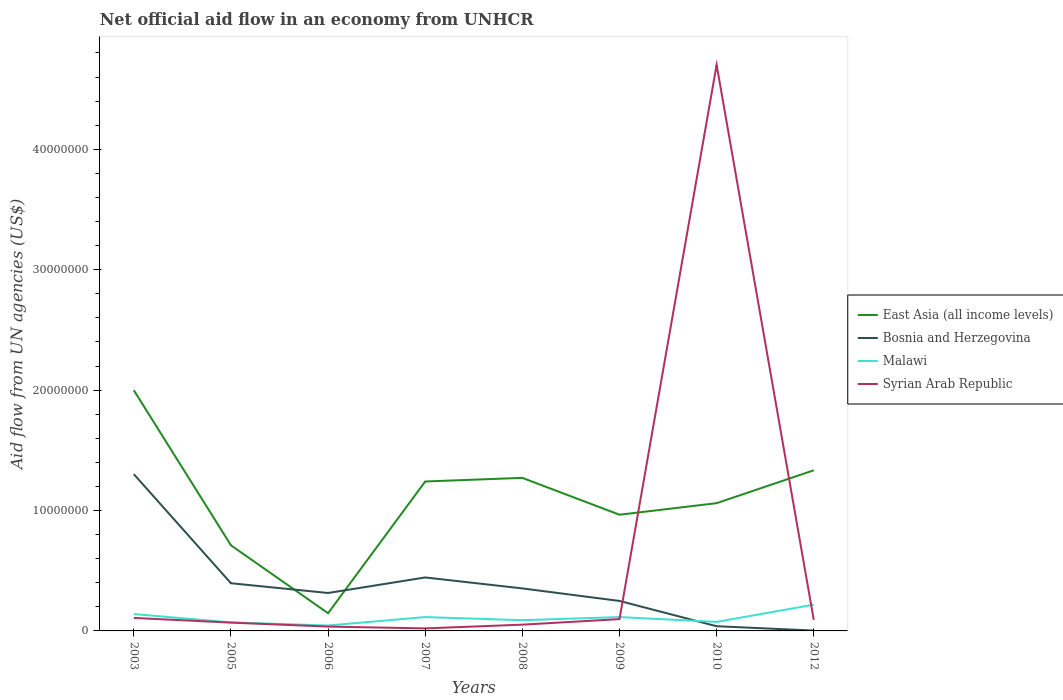How many different coloured lines are there?
Provide a short and direct response. 4. What is the total net official aid flow in Bosnia and Herzegovina in the graph?
Your response must be concise. 2.10e+06. What is the difference between the highest and the second highest net official aid flow in East Asia (all income levels)?
Your answer should be very brief. 1.85e+07. How many lines are there?
Provide a succinct answer. 4. What is the difference between two consecutive major ticks on the Y-axis?
Give a very brief answer. 1.00e+07. Are the values on the major ticks of Y-axis written in scientific E-notation?
Offer a very short reply. No. Does the graph contain grids?
Provide a short and direct response. No. What is the title of the graph?
Give a very brief answer. Net official aid flow in an economy from UNHCR. What is the label or title of the X-axis?
Provide a short and direct response. Years. What is the label or title of the Y-axis?
Offer a very short reply. Aid flow from UN agencies (US$). What is the Aid flow from UN agencies (US$) in East Asia (all income levels) in 2003?
Make the answer very short. 2.00e+07. What is the Aid flow from UN agencies (US$) of Bosnia and Herzegovina in 2003?
Offer a terse response. 1.30e+07. What is the Aid flow from UN agencies (US$) in Malawi in 2003?
Offer a very short reply. 1.40e+06. What is the Aid flow from UN agencies (US$) of Syrian Arab Republic in 2003?
Provide a succinct answer. 1.08e+06. What is the Aid flow from UN agencies (US$) in East Asia (all income levels) in 2005?
Offer a terse response. 7.11e+06. What is the Aid flow from UN agencies (US$) of Bosnia and Herzegovina in 2005?
Provide a succinct answer. 3.96e+06. What is the Aid flow from UN agencies (US$) of Malawi in 2005?
Ensure brevity in your answer.  7.10e+05. What is the Aid flow from UN agencies (US$) of Syrian Arab Republic in 2005?
Offer a very short reply. 6.90e+05. What is the Aid flow from UN agencies (US$) of East Asia (all income levels) in 2006?
Offer a very short reply. 1.47e+06. What is the Aid flow from UN agencies (US$) of Bosnia and Herzegovina in 2006?
Provide a succinct answer. 3.15e+06. What is the Aid flow from UN agencies (US$) in Malawi in 2006?
Ensure brevity in your answer.  4.50e+05. What is the Aid flow from UN agencies (US$) in Syrian Arab Republic in 2006?
Your answer should be compact. 3.60e+05. What is the Aid flow from UN agencies (US$) of East Asia (all income levels) in 2007?
Ensure brevity in your answer.  1.24e+07. What is the Aid flow from UN agencies (US$) in Bosnia and Herzegovina in 2007?
Offer a very short reply. 4.44e+06. What is the Aid flow from UN agencies (US$) of Malawi in 2007?
Keep it short and to the point. 1.15e+06. What is the Aid flow from UN agencies (US$) of Syrian Arab Republic in 2007?
Provide a short and direct response. 2.10e+05. What is the Aid flow from UN agencies (US$) in East Asia (all income levels) in 2008?
Your answer should be very brief. 1.27e+07. What is the Aid flow from UN agencies (US$) of Bosnia and Herzegovina in 2008?
Provide a succinct answer. 3.53e+06. What is the Aid flow from UN agencies (US$) of Malawi in 2008?
Offer a terse response. 8.90e+05. What is the Aid flow from UN agencies (US$) of Syrian Arab Republic in 2008?
Ensure brevity in your answer.  5.20e+05. What is the Aid flow from UN agencies (US$) in East Asia (all income levels) in 2009?
Your response must be concise. 9.65e+06. What is the Aid flow from UN agencies (US$) of Bosnia and Herzegovina in 2009?
Give a very brief answer. 2.49e+06. What is the Aid flow from UN agencies (US$) in Malawi in 2009?
Offer a very short reply. 1.15e+06. What is the Aid flow from UN agencies (US$) in Syrian Arab Republic in 2009?
Your answer should be very brief. 9.80e+05. What is the Aid flow from UN agencies (US$) of East Asia (all income levels) in 2010?
Make the answer very short. 1.06e+07. What is the Aid flow from UN agencies (US$) of Malawi in 2010?
Give a very brief answer. 7.50e+05. What is the Aid flow from UN agencies (US$) in Syrian Arab Republic in 2010?
Provide a short and direct response. 4.70e+07. What is the Aid flow from UN agencies (US$) in East Asia (all income levels) in 2012?
Your answer should be very brief. 1.33e+07. What is the Aid flow from UN agencies (US$) of Bosnia and Herzegovina in 2012?
Provide a succinct answer. 3.00e+04. What is the Aid flow from UN agencies (US$) of Malawi in 2012?
Offer a very short reply. 2.18e+06. What is the Aid flow from UN agencies (US$) of Syrian Arab Republic in 2012?
Keep it short and to the point. 9.20e+05. Across all years, what is the maximum Aid flow from UN agencies (US$) in East Asia (all income levels)?
Offer a terse response. 2.00e+07. Across all years, what is the maximum Aid flow from UN agencies (US$) of Bosnia and Herzegovina?
Make the answer very short. 1.30e+07. Across all years, what is the maximum Aid flow from UN agencies (US$) of Malawi?
Your answer should be compact. 2.18e+06. Across all years, what is the maximum Aid flow from UN agencies (US$) of Syrian Arab Republic?
Your answer should be very brief. 4.70e+07. Across all years, what is the minimum Aid flow from UN agencies (US$) in East Asia (all income levels)?
Your answer should be very brief. 1.47e+06. Across all years, what is the minimum Aid flow from UN agencies (US$) of Bosnia and Herzegovina?
Ensure brevity in your answer.  3.00e+04. What is the total Aid flow from UN agencies (US$) in East Asia (all income levels) in the graph?
Your response must be concise. 8.73e+07. What is the total Aid flow from UN agencies (US$) in Bosnia and Herzegovina in the graph?
Your answer should be very brief. 3.10e+07. What is the total Aid flow from UN agencies (US$) in Malawi in the graph?
Make the answer very short. 8.68e+06. What is the total Aid flow from UN agencies (US$) of Syrian Arab Republic in the graph?
Keep it short and to the point. 5.18e+07. What is the difference between the Aid flow from UN agencies (US$) in East Asia (all income levels) in 2003 and that in 2005?
Offer a terse response. 1.29e+07. What is the difference between the Aid flow from UN agencies (US$) in Bosnia and Herzegovina in 2003 and that in 2005?
Keep it short and to the point. 9.06e+06. What is the difference between the Aid flow from UN agencies (US$) in Malawi in 2003 and that in 2005?
Your answer should be very brief. 6.90e+05. What is the difference between the Aid flow from UN agencies (US$) of East Asia (all income levels) in 2003 and that in 2006?
Make the answer very short. 1.85e+07. What is the difference between the Aid flow from UN agencies (US$) of Bosnia and Herzegovina in 2003 and that in 2006?
Keep it short and to the point. 9.87e+06. What is the difference between the Aid flow from UN agencies (US$) in Malawi in 2003 and that in 2006?
Offer a terse response. 9.50e+05. What is the difference between the Aid flow from UN agencies (US$) of Syrian Arab Republic in 2003 and that in 2006?
Provide a succinct answer. 7.20e+05. What is the difference between the Aid flow from UN agencies (US$) of East Asia (all income levels) in 2003 and that in 2007?
Offer a terse response. 7.58e+06. What is the difference between the Aid flow from UN agencies (US$) in Bosnia and Herzegovina in 2003 and that in 2007?
Provide a short and direct response. 8.58e+06. What is the difference between the Aid flow from UN agencies (US$) of Malawi in 2003 and that in 2007?
Your answer should be compact. 2.50e+05. What is the difference between the Aid flow from UN agencies (US$) in Syrian Arab Republic in 2003 and that in 2007?
Your answer should be compact. 8.70e+05. What is the difference between the Aid flow from UN agencies (US$) of East Asia (all income levels) in 2003 and that in 2008?
Provide a succinct answer. 7.28e+06. What is the difference between the Aid flow from UN agencies (US$) of Bosnia and Herzegovina in 2003 and that in 2008?
Ensure brevity in your answer.  9.49e+06. What is the difference between the Aid flow from UN agencies (US$) in Malawi in 2003 and that in 2008?
Provide a succinct answer. 5.10e+05. What is the difference between the Aid flow from UN agencies (US$) in Syrian Arab Republic in 2003 and that in 2008?
Give a very brief answer. 5.60e+05. What is the difference between the Aid flow from UN agencies (US$) of East Asia (all income levels) in 2003 and that in 2009?
Your answer should be very brief. 1.03e+07. What is the difference between the Aid flow from UN agencies (US$) in Bosnia and Herzegovina in 2003 and that in 2009?
Your answer should be compact. 1.05e+07. What is the difference between the Aid flow from UN agencies (US$) in East Asia (all income levels) in 2003 and that in 2010?
Keep it short and to the point. 9.38e+06. What is the difference between the Aid flow from UN agencies (US$) of Bosnia and Herzegovina in 2003 and that in 2010?
Your response must be concise. 1.26e+07. What is the difference between the Aid flow from UN agencies (US$) of Malawi in 2003 and that in 2010?
Your answer should be very brief. 6.50e+05. What is the difference between the Aid flow from UN agencies (US$) of Syrian Arab Republic in 2003 and that in 2010?
Keep it short and to the point. -4.59e+07. What is the difference between the Aid flow from UN agencies (US$) in East Asia (all income levels) in 2003 and that in 2012?
Offer a very short reply. 6.65e+06. What is the difference between the Aid flow from UN agencies (US$) of Bosnia and Herzegovina in 2003 and that in 2012?
Give a very brief answer. 1.30e+07. What is the difference between the Aid flow from UN agencies (US$) of Malawi in 2003 and that in 2012?
Your answer should be compact. -7.80e+05. What is the difference between the Aid flow from UN agencies (US$) in Syrian Arab Republic in 2003 and that in 2012?
Make the answer very short. 1.60e+05. What is the difference between the Aid flow from UN agencies (US$) of East Asia (all income levels) in 2005 and that in 2006?
Offer a very short reply. 5.64e+06. What is the difference between the Aid flow from UN agencies (US$) of Bosnia and Herzegovina in 2005 and that in 2006?
Offer a terse response. 8.10e+05. What is the difference between the Aid flow from UN agencies (US$) of Syrian Arab Republic in 2005 and that in 2006?
Give a very brief answer. 3.30e+05. What is the difference between the Aid flow from UN agencies (US$) of East Asia (all income levels) in 2005 and that in 2007?
Offer a terse response. -5.30e+06. What is the difference between the Aid flow from UN agencies (US$) in Bosnia and Herzegovina in 2005 and that in 2007?
Offer a very short reply. -4.80e+05. What is the difference between the Aid flow from UN agencies (US$) in Malawi in 2005 and that in 2007?
Keep it short and to the point. -4.40e+05. What is the difference between the Aid flow from UN agencies (US$) in East Asia (all income levels) in 2005 and that in 2008?
Your answer should be very brief. -5.60e+06. What is the difference between the Aid flow from UN agencies (US$) in Bosnia and Herzegovina in 2005 and that in 2008?
Provide a succinct answer. 4.30e+05. What is the difference between the Aid flow from UN agencies (US$) of Malawi in 2005 and that in 2008?
Ensure brevity in your answer.  -1.80e+05. What is the difference between the Aid flow from UN agencies (US$) of East Asia (all income levels) in 2005 and that in 2009?
Provide a succinct answer. -2.54e+06. What is the difference between the Aid flow from UN agencies (US$) of Bosnia and Herzegovina in 2005 and that in 2009?
Offer a terse response. 1.47e+06. What is the difference between the Aid flow from UN agencies (US$) in Malawi in 2005 and that in 2009?
Provide a short and direct response. -4.40e+05. What is the difference between the Aid flow from UN agencies (US$) in East Asia (all income levels) in 2005 and that in 2010?
Give a very brief answer. -3.50e+06. What is the difference between the Aid flow from UN agencies (US$) of Bosnia and Herzegovina in 2005 and that in 2010?
Give a very brief answer. 3.57e+06. What is the difference between the Aid flow from UN agencies (US$) of Malawi in 2005 and that in 2010?
Offer a terse response. -4.00e+04. What is the difference between the Aid flow from UN agencies (US$) of Syrian Arab Republic in 2005 and that in 2010?
Make the answer very short. -4.63e+07. What is the difference between the Aid flow from UN agencies (US$) of East Asia (all income levels) in 2005 and that in 2012?
Keep it short and to the point. -6.23e+06. What is the difference between the Aid flow from UN agencies (US$) of Bosnia and Herzegovina in 2005 and that in 2012?
Provide a short and direct response. 3.93e+06. What is the difference between the Aid flow from UN agencies (US$) of Malawi in 2005 and that in 2012?
Ensure brevity in your answer.  -1.47e+06. What is the difference between the Aid flow from UN agencies (US$) of East Asia (all income levels) in 2006 and that in 2007?
Offer a very short reply. -1.09e+07. What is the difference between the Aid flow from UN agencies (US$) in Bosnia and Herzegovina in 2006 and that in 2007?
Your answer should be compact. -1.29e+06. What is the difference between the Aid flow from UN agencies (US$) of Malawi in 2006 and that in 2007?
Give a very brief answer. -7.00e+05. What is the difference between the Aid flow from UN agencies (US$) of Syrian Arab Republic in 2006 and that in 2007?
Make the answer very short. 1.50e+05. What is the difference between the Aid flow from UN agencies (US$) of East Asia (all income levels) in 2006 and that in 2008?
Give a very brief answer. -1.12e+07. What is the difference between the Aid flow from UN agencies (US$) in Bosnia and Herzegovina in 2006 and that in 2008?
Make the answer very short. -3.80e+05. What is the difference between the Aid flow from UN agencies (US$) of Malawi in 2006 and that in 2008?
Ensure brevity in your answer.  -4.40e+05. What is the difference between the Aid flow from UN agencies (US$) in Syrian Arab Republic in 2006 and that in 2008?
Make the answer very short. -1.60e+05. What is the difference between the Aid flow from UN agencies (US$) of East Asia (all income levels) in 2006 and that in 2009?
Your answer should be very brief. -8.18e+06. What is the difference between the Aid flow from UN agencies (US$) in Bosnia and Herzegovina in 2006 and that in 2009?
Your answer should be very brief. 6.60e+05. What is the difference between the Aid flow from UN agencies (US$) of Malawi in 2006 and that in 2009?
Your answer should be very brief. -7.00e+05. What is the difference between the Aid flow from UN agencies (US$) in Syrian Arab Republic in 2006 and that in 2009?
Ensure brevity in your answer.  -6.20e+05. What is the difference between the Aid flow from UN agencies (US$) of East Asia (all income levels) in 2006 and that in 2010?
Make the answer very short. -9.14e+06. What is the difference between the Aid flow from UN agencies (US$) of Bosnia and Herzegovina in 2006 and that in 2010?
Make the answer very short. 2.76e+06. What is the difference between the Aid flow from UN agencies (US$) of Syrian Arab Republic in 2006 and that in 2010?
Your response must be concise. -4.66e+07. What is the difference between the Aid flow from UN agencies (US$) of East Asia (all income levels) in 2006 and that in 2012?
Keep it short and to the point. -1.19e+07. What is the difference between the Aid flow from UN agencies (US$) of Bosnia and Herzegovina in 2006 and that in 2012?
Ensure brevity in your answer.  3.12e+06. What is the difference between the Aid flow from UN agencies (US$) in Malawi in 2006 and that in 2012?
Your response must be concise. -1.73e+06. What is the difference between the Aid flow from UN agencies (US$) in Syrian Arab Republic in 2006 and that in 2012?
Your answer should be very brief. -5.60e+05. What is the difference between the Aid flow from UN agencies (US$) of East Asia (all income levels) in 2007 and that in 2008?
Provide a succinct answer. -3.00e+05. What is the difference between the Aid flow from UN agencies (US$) of Bosnia and Herzegovina in 2007 and that in 2008?
Provide a short and direct response. 9.10e+05. What is the difference between the Aid flow from UN agencies (US$) of Malawi in 2007 and that in 2008?
Offer a very short reply. 2.60e+05. What is the difference between the Aid flow from UN agencies (US$) of Syrian Arab Republic in 2007 and that in 2008?
Your answer should be compact. -3.10e+05. What is the difference between the Aid flow from UN agencies (US$) in East Asia (all income levels) in 2007 and that in 2009?
Your answer should be very brief. 2.76e+06. What is the difference between the Aid flow from UN agencies (US$) of Bosnia and Herzegovina in 2007 and that in 2009?
Keep it short and to the point. 1.95e+06. What is the difference between the Aid flow from UN agencies (US$) in Malawi in 2007 and that in 2009?
Keep it short and to the point. 0. What is the difference between the Aid flow from UN agencies (US$) in Syrian Arab Republic in 2007 and that in 2009?
Offer a terse response. -7.70e+05. What is the difference between the Aid flow from UN agencies (US$) in East Asia (all income levels) in 2007 and that in 2010?
Make the answer very short. 1.80e+06. What is the difference between the Aid flow from UN agencies (US$) in Bosnia and Herzegovina in 2007 and that in 2010?
Your answer should be compact. 4.05e+06. What is the difference between the Aid flow from UN agencies (US$) of Malawi in 2007 and that in 2010?
Offer a very short reply. 4.00e+05. What is the difference between the Aid flow from UN agencies (US$) of Syrian Arab Republic in 2007 and that in 2010?
Offer a very short reply. -4.68e+07. What is the difference between the Aid flow from UN agencies (US$) in East Asia (all income levels) in 2007 and that in 2012?
Make the answer very short. -9.30e+05. What is the difference between the Aid flow from UN agencies (US$) in Bosnia and Herzegovina in 2007 and that in 2012?
Provide a succinct answer. 4.41e+06. What is the difference between the Aid flow from UN agencies (US$) in Malawi in 2007 and that in 2012?
Give a very brief answer. -1.03e+06. What is the difference between the Aid flow from UN agencies (US$) in Syrian Arab Republic in 2007 and that in 2012?
Your answer should be very brief. -7.10e+05. What is the difference between the Aid flow from UN agencies (US$) of East Asia (all income levels) in 2008 and that in 2009?
Give a very brief answer. 3.06e+06. What is the difference between the Aid flow from UN agencies (US$) of Bosnia and Herzegovina in 2008 and that in 2009?
Your answer should be very brief. 1.04e+06. What is the difference between the Aid flow from UN agencies (US$) in Syrian Arab Republic in 2008 and that in 2009?
Provide a short and direct response. -4.60e+05. What is the difference between the Aid flow from UN agencies (US$) of East Asia (all income levels) in 2008 and that in 2010?
Keep it short and to the point. 2.10e+06. What is the difference between the Aid flow from UN agencies (US$) of Bosnia and Herzegovina in 2008 and that in 2010?
Provide a succinct answer. 3.14e+06. What is the difference between the Aid flow from UN agencies (US$) of Syrian Arab Republic in 2008 and that in 2010?
Offer a very short reply. -4.65e+07. What is the difference between the Aid flow from UN agencies (US$) of East Asia (all income levels) in 2008 and that in 2012?
Make the answer very short. -6.30e+05. What is the difference between the Aid flow from UN agencies (US$) of Bosnia and Herzegovina in 2008 and that in 2012?
Make the answer very short. 3.50e+06. What is the difference between the Aid flow from UN agencies (US$) in Malawi in 2008 and that in 2012?
Your answer should be very brief. -1.29e+06. What is the difference between the Aid flow from UN agencies (US$) of Syrian Arab Republic in 2008 and that in 2012?
Make the answer very short. -4.00e+05. What is the difference between the Aid flow from UN agencies (US$) in East Asia (all income levels) in 2009 and that in 2010?
Your response must be concise. -9.60e+05. What is the difference between the Aid flow from UN agencies (US$) of Bosnia and Herzegovina in 2009 and that in 2010?
Provide a succinct answer. 2.10e+06. What is the difference between the Aid flow from UN agencies (US$) in Syrian Arab Republic in 2009 and that in 2010?
Your response must be concise. -4.60e+07. What is the difference between the Aid flow from UN agencies (US$) of East Asia (all income levels) in 2009 and that in 2012?
Your answer should be very brief. -3.69e+06. What is the difference between the Aid flow from UN agencies (US$) in Bosnia and Herzegovina in 2009 and that in 2012?
Your answer should be very brief. 2.46e+06. What is the difference between the Aid flow from UN agencies (US$) in Malawi in 2009 and that in 2012?
Provide a short and direct response. -1.03e+06. What is the difference between the Aid flow from UN agencies (US$) of Syrian Arab Republic in 2009 and that in 2012?
Keep it short and to the point. 6.00e+04. What is the difference between the Aid flow from UN agencies (US$) of East Asia (all income levels) in 2010 and that in 2012?
Provide a succinct answer. -2.73e+06. What is the difference between the Aid flow from UN agencies (US$) in Malawi in 2010 and that in 2012?
Offer a terse response. -1.43e+06. What is the difference between the Aid flow from UN agencies (US$) of Syrian Arab Republic in 2010 and that in 2012?
Your answer should be compact. 4.61e+07. What is the difference between the Aid flow from UN agencies (US$) in East Asia (all income levels) in 2003 and the Aid flow from UN agencies (US$) in Bosnia and Herzegovina in 2005?
Provide a succinct answer. 1.60e+07. What is the difference between the Aid flow from UN agencies (US$) in East Asia (all income levels) in 2003 and the Aid flow from UN agencies (US$) in Malawi in 2005?
Keep it short and to the point. 1.93e+07. What is the difference between the Aid flow from UN agencies (US$) in East Asia (all income levels) in 2003 and the Aid flow from UN agencies (US$) in Syrian Arab Republic in 2005?
Provide a succinct answer. 1.93e+07. What is the difference between the Aid flow from UN agencies (US$) of Bosnia and Herzegovina in 2003 and the Aid flow from UN agencies (US$) of Malawi in 2005?
Provide a short and direct response. 1.23e+07. What is the difference between the Aid flow from UN agencies (US$) in Bosnia and Herzegovina in 2003 and the Aid flow from UN agencies (US$) in Syrian Arab Republic in 2005?
Provide a short and direct response. 1.23e+07. What is the difference between the Aid flow from UN agencies (US$) of Malawi in 2003 and the Aid flow from UN agencies (US$) of Syrian Arab Republic in 2005?
Ensure brevity in your answer.  7.10e+05. What is the difference between the Aid flow from UN agencies (US$) in East Asia (all income levels) in 2003 and the Aid flow from UN agencies (US$) in Bosnia and Herzegovina in 2006?
Ensure brevity in your answer.  1.68e+07. What is the difference between the Aid flow from UN agencies (US$) in East Asia (all income levels) in 2003 and the Aid flow from UN agencies (US$) in Malawi in 2006?
Ensure brevity in your answer.  1.95e+07. What is the difference between the Aid flow from UN agencies (US$) of East Asia (all income levels) in 2003 and the Aid flow from UN agencies (US$) of Syrian Arab Republic in 2006?
Provide a short and direct response. 1.96e+07. What is the difference between the Aid flow from UN agencies (US$) of Bosnia and Herzegovina in 2003 and the Aid flow from UN agencies (US$) of Malawi in 2006?
Keep it short and to the point. 1.26e+07. What is the difference between the Aid flow from UN agencies (US$) in Bosnia and Herzegovina in 2003 and the Aid flow from UN agencies (US$) in Syrian Arab Republic in 2006?
Your response must be concise. 1.27e+07. What is the difference between the Aid flow from UN agencies (US$) in Malawi in 2003 and the Aid flow from UN agencies (US$) in Syrian Arab Republic in 2006?
Your answer should be very brief. 1.04e+06. What is the difference between the Aid flow from UN agencies (US$) in East Asia (all income levels) in 2003 and the Aid flow from UN agencies (US$) in Bosnia and Herzegovina in 2007?
Provide a short and direct response. 1.56e+07. What is the difference between the Aid flow from UN agencies (US$) in East Asia (all income levels) in 2003 and the Aid flow from UN agencies (US$) in Malawi in 2007?
Your answer should be very brief. 1.88e+07. What is the difference between the Aid flow from UN agencies (US$) in East Asia (all income levels) in 2003 and the Aid flow from UN agencies (US$) in Syrian Arab Republic in 2007?
Your response must be concise. 1.98e+07. What is the difference between the Aid flow from UN agencies (US$) in Bosnia and Herzegovina in 2003 and the Aid flow from UN agencies (US$) in Malawi in 2007?
Your answer should be very brief. 1.19e+07. What is the difference between the Aid flow from UN agencies (US$) in Bosnia and Herzegovina in 2003 and the Aid flow from UN agencies (US$) in Syrian Arab Republic in 2007?
Give a very brief answer. 1.28e+07. What is the difference between the Aid flow from UN agencies (US$) in Malawi in 2003 and the Aid flow from UN agencies (US$) in Syrian Arab Republic in 2007?
Your answer should be compact. 1.19e+06. What is the difference between the Aid flow from UN agencies (US$) in East Asia (all income levels) in 2003 and the Aid flow from UN agencies (US$) in Bosnia and Herzegovina in 2008?
Provide a short and direct response. 1.65e+07. What is the difference between the Aid flow from UN agencies (US$) of East Asia (all income levels) in 2003 and the Aid flow from UN agencies (US$) of Malawi in 2008?
Make the answer very short. 1.91e+07. What is the difference between the Aid flow from UN agencies (US$) in East Asia (all income levels) in 2003 and the Aid flow from UN agencies (US$) in Syrian Arab Republic in 2008?
Make the answer very short. 1.95e+07. What is the difference between the Aid flow from UN agencies (US$) of Bosnia and Herzegovina in 2003 and the Aid flow from UN agencies (US$) of Malawi in 2008?
Make the answer very short. 1.21e+07. What is the difference between the Aid flow from UN agencies (US$) in Bosnia and Herzegovina in 2003 and the Aid flow from UN agencies (US$) in Syrian Arab Republic in 2008?
Ensure brevity in your answer.  1.25e+07. What is the difference between the Aid flow from UN agencies (US$) of Malawi in 2003 and the Aid flow from UN agencies (US$) of Syrian Arab Republic in 2008?
Make the answer very short. 8.80e+05. What is the difference between the Aid flow from UN agencies (US$) in East Asia (all income levels) in 2003 and the Aid flow from UN agencies (US$) in Bosnia and Herzegovina in 2009?
Make the answer very short. 1.75e+07. What is the difference between the Aid flow from UN agencies (US$) in East Asia (all income levels) in 2003 and the Aid flow from UN agencies (US$) in Malawi in 2009?
Your answer should be compact. 1.88e+07. What is the difference between the Aid flow from UN agencies (US$) of East Asia (all income levels) in 2003 and the Aid flow from UN agencies (US$) of Syrian Arab Republic in 2009?
Your answer should be very brief. 1.90e+07. What is the difference between the Aid flow from UN agencies (US$) of Bosnia and Herzegovina in 2003 and the Aid flow from UN agencies (US$) of Malawi in 2009?
Give a very brief answer. 1.19e+07. What is the difference between the Aid flow from UN agencies (US$) in Bosnia and Herzegovina in 2003 and the Aid flow from UN agencies (US$) in Syrian Arab Republic in 2009?
Give a very brief answer. 1.20e+07. What is the difference between the Aid flow from UN agencies (US$) of East Asia (all income levels) in 2003 and the Aid flow from UN agencies (US$) of Bosnia and Herzegovina in 2010?
Offer a very short reply. 1.96e+07. What is the difference between the Aid flow from UN agencies (US$) in East Asia (all income levels) in 2003 and the Aid flow from UN agencies (US$) in Malawi in 2010?
Your response must be concise. 1.92e+07. What is the difference between the Aid flow from UN agencies (US$) of East Asia (all income levels) in 2003 and the Aid flow from UN agencies (US$) of Syrian Arab Republic in 2010?
Offer a very short reply. -2.70e+07. What is the difference between the Aid flow from UN agencies (US$) of Bosnia and Herzegovina in 2003 and the Aid flow from UN agencies (US$) of Malawi in 2010?
Provide a succinct answer. 1.23e+07. What is the difference between the Aid flow from UN agencies (US$) of Bosnia and Herzegovina in 2003 and the Aid flow from UN agencies (US$) of Syrian Arab Republic in 2010?
Offer a terse response. -3.40e+07. What is the difference between the Aid flow from UN agencies (US$) of Malawi in 2003 and the Aid flow from UN agencies (US$) of Syrian Arab Republic in 2010?
Provide a short and direct response. -4.56e+07. What is the difference between the Aid flow from UN agencies (US$) in East Asia (all income levels) in 2003 and the Aid flow from UN agencies (US$) in Bosnia and Herzegovina in 2012?
Keep it short and to the point. 2.00e+07. What is the difference between the Aid flow from UN agencies (US$) in East Asia (all income levels) in 2003 and the Aid flow from UN agencies (US$) in Malawi in 2012?
Provide a short and direct response. 1.78e+07. What is the difference between the Aid flow from UN agencies (US$) of East Asia (all income levels) in 2003 and the Aid flow from UN agencies (US$) of Syrian Arab Republic in 2012?
Your response must be concise. 1.91e+07. What is the difference between the Aid flow from UN agencies (US$) of Bosnia and Herzegovina in 2003 and the Aid flow from UN agencies (US$) of Malawi in 2012?
Your answer should be compact. 1.08e+07. What is the difference between the Aid flow from UN agencies (US$) in Bosnia and Herzegovina in 2003 and the Aid flow from UN agencies (US$) in Syrian Arab Republic in 2012?
Your response must be concise. 1.21e+07. What is the difference between the Aid flow from UN agencies (US$) of East Asia (all income levels) in 2005 and the Aid flow from UN agencies (US$) of Bosnia and Herzegovina in 2006?
Your answer should be compact. 3.96e+06. What is the difference between the Aid flow from UN agencies (US$) of East Asia (all income levels) in 2005 and the Aid flow from UN agencies (US$) of Malawi in 2006?
Your answer should be very brief. 6.66e+06. What is the difference between the Aid flow from UN agencies (US$) of East Asia (all income levels) in 2005 and the Aid flow from UN agencies (US$) of Syrian Arab Republic in 2006?
Offer a very short reply. 6.75e+06. What is the difference between the Aid flow from UN agencies (US$) in Bosnia and Herzegovina in 2005 and the Aid flow from UN agencies (US$) in Malawi in 2006?
Make the answer very short. 3.51e+06. What is the difference between the Aid flow from UN agencies (US$) of Bosnia and Herzegovina in 2005 and the Aid flow from UN agencies (US$) of Syrian Arab Republic in 2006?
Provide a short and direct response. 3.60e+06. What is the difference between the Aid flow from UN agencies (US$) of East Asia (all income levels) in 2005 and the Aid flow from UN agencies (US$) of Bosnia and Herzegovina in 2007?
Offer a terse response. 2.67e+06. What is the difference between the Aid flow from UN agencies (US$) in East Asia (all income levels) in 2005 and the Aid flow from UN agencies (US$) in Malawi in 2007?
Offer a terse response. 5.96e+06. What is the difference between the Aid flow from UN agencies (US$) in East Asia (all income levels) in 2005 and the Aid flow from UN agencies (US$) in Syrian Arab Republic in 2007?
Offer a terse response. 6.90e+06. What is the difference between the Aid flow from UN agencies (US$) of Bosnia and Herzegovina in 2005 and the Aid flow from UN agencies (US$) of Malawi in 2007?
Your answer should be compact. 2.81e+06. What is the difference between the Aid flow from UN agencies (US$) of Bosnia and Herzegovina in 2005 and the Aid flow from UN agencies (US$) of Syrian Arab Republic in 2007?
Your answer should be compact. 3.75e+06. What is the difference between the Aid flow from UN agencies (US$) in Malawi in 2005 and the Aid flow from UN agencies (US$) in Syrian Arab Republic in 2007?
Offer a very short reply. 5.00e+05. What is the difference between the Aid flow from UN agencies (US$) of East Asia (all income levels) in 2005 and the Aid flow from UN agencies (US$) of Bosnia and Herzegovina in 2008?
Keep it short and to the point. 3.58e+06. What is the difference between the Aid flow from UN agencies (US$) in East Asia (all income levels) in 2005 and the Aid flow from UN agencies (US$) in Malawi in 2008?
Ensure brevity in your answer.  6.22e+06. What is the difference between the Aid flow from UN agencies (US$) of East Asia (all income levels) in 2005 and the Aid flow from UN agencies (US$) of Syrian Arab Republic in 2008?
Offer a very short reply. 6.59e+06. What is the difference between the Aid flow from UN agencies (US$) in Bosnia and Herzegovina in 2005 and the Aid flow from UN agencies (US$) in Malawi in 2008?
Offer a very short reply. 3.07e+06. What is the difference between the Aid flow from UN agencies (US$) of Bosnia and Herzegovina in 2005 and the Aid flow from UN agencies (US$) of Syrian Arab Republic in 2008?
Your answer should be compact. 3.44e+06. What is the difference between the Aid flow from UN agencies (US$) in Malawi in 2005 and the Aid flow from UN agencies (US$) in Syrian Arab Republic in 2008?
Your answer should be compact. 1.90e+05. What is the difference between the Aid flow from UN agencies (US$) of East Asia (all income levels) in 2005 and the Aid flow from UN agencies (US$) of Bosnia and Herzegovina in 2009?
Provide a succinct answer. 4.62e+06. What is the difference between the Aid flow from UN agencies (US$) in East Asia (all income levels) in 2005 and the Aid flow from UN agencies (US$) in Malawi in 2009?
Provide a succinct answer. 5.96e+06. What is the difference between the Aid flow from UN agencies (US$) in East Asia (all income levels) in 2005 and the Aid flow from UN agencies (US$) in Syrian Arab Republic in 2009?
Your answer should be compact. 6.13e+06. What is the difference between the Aid flow from UN agencies (US$) in Bosnia and Herzegovina in 2005 and the Aid flow from UN agencies (US$) in Malawi in 2009?
Your answer should be compact. 2.81e+06. What is the difference between the Aid flow from UN agencies (US$) in Bosnia and Herzegovina in 2005 and the Aid flow from UN agencies (US$) in Syrian Arab Republic in 2009?
Give a very brief answer. 2.98e+06. What is the difference between the Aid flow from UN agencies (US$) of East Asia (all income levels) in 2005 and the Aid flow from UN agencies (US$) of Bosnia and Herzegovina in 2010?
Your answer should be compact. 6.72e+06. What is the difference between the Aid flow from UN agencies (US$) in East Asia (all income levels) in 2005 and the Aid flow from UN agencies (US$) in Malawi in 2010?
Offer a very short reply. 6.36e+06. What is the difference between the Aid flow from UN agencies (US$) in East Asia (all income levels) in 2005 and the Aid flow from UN agencies (US$) in Syrian Arab Republic in 2010?
Offer a terse response. -3.99e+07. What is the difference between the Aid flow from UN agencies (US$) in Bosnia and Herzegovina in 2005 and the Aid flow from UN agencies (US$) in Malawi in 2010?
Your answer should be compact. 3.21e+06. What is the difference between the Aid flow from UN agencies (US$) of Bosnia and Herzegovina in 2005 and the Aid flow from UN agencies (US$) of Syrian Arab Republic in 2010?
Your answer should be very brief. -4.30e+07. What is the difference between the Aid flow from UN agencies (US$) of Malawi in 2005 and the Aid flow from UN agencies (US$) of Syrian Arab Republic in 2010?
Keep it short and to the point. -4.63e+07. What is the difference between the Aid flow from UN agencies (US$) in East Asia (all income levels) in 2005 and the Aid flow from UN agencies (US$) in Bosnia and Herzegovina in 2012?
Offer a very short reply. 7.08e+06. What is the difference between the Aid flow from UN agencies (US$) in East Asia (all income levels) in 2005 and the Aid flow from UN agencies (US$) in Malawi in 2012?
Give a very brief answer. 4.93e+06. What is the difference between the Aid flow from UN agencies (US$) of East Asia (all income levels) in 2005 and the Aid flow from UN agencies (US$) of Syrian Arab Republic in 2012?
Your answer should be compact. 6.19e+06. What is the difference between the Aid flow from UN agencies (US$) in Bosnia and Herzegovina in 2005 and the Aid flow from UN agencies (US$) in Malawi in 2012?
Keep it short and to the point. 1.78e+06. What is the difference between the Aid flow from UN agencies (US$) of Bosnia and Herzegovina in 2005 and the Aid flow from UN agencies (US$) of Syrian Arab Republic in 2012?
Provide a short and direct response. 3.04e+06. What is the difference between the Aid flow from UN agencies (US$) of East Asia (all income levels) in 2006 and the Aid flow from UN agencies (US$) of Bosnia and Herzegovina in 2007?
Provide a succinct answer. -2.97e+06. What is the difference between the Aid flow from UN agencies (US$) in East Asia (all income levels) in 2006 and the Aid flow from UN agencies (US$) in Malawi in 2007?
Ensure brevity in your answer.  3.20e+05. What is the difference between the Aid flow from UN agencies (US$) in East Asia (all income levels) in 2006 and the Aid flow from UN agencies (US$) in Syrian Arab Republic in 2007?
Provide a succinct answer. 1.26e+06. What is the difference between the Aid flow from UN agencies (US$) of Bosnia and Herzegovina in 2006 and the Aid flow from UN agencies (US$) of Syrian Arab Republic in 2007?
Provide a succinct answer. 2.94e+06. What is the difference between the Aid flow from UN agencies (US$) of Malawi in 2006 and the Aid flow from UN agencies (US$) of Syrian Arab Republic in 2007?
Your answer should be very brief. 2.40e+05. What is the difference between the Aid flow from UN agencies (US$) of East Asia (all income levels) in 2006 and the Aid flow from UN agencies (US$) of Bosnia and Herzegovina in 2008?
Your answer should be compact. -2.06e+06. What is the difference between the Aid flow from UN agencies (US$) in East Asia (all income levels) in 2006 and the Aid flow from UN agencies (US$) in Malawi in 2008?
Keep it short and to the point. 5.80e+05. What is the difference between the Aid flow from UN agencies (US$) of East Asia (all income levels) in 2006 and the Aid flow from UN agencies (US$) of Syrian Arab Republic in 2008?
Your answer should be compact. 9.50e+05. What is the difference between the Aid flow from UN agencies (US$) of Bosnia and Herzegovina in 2006 and the Aid flow from UN agencies (US$) of Malawi in 2008?
Your answer should be compact. 2.26e+06. What is the difference between the Aid flow from UN agencies (US$) in Bosnia and Herzegovina in 2006 and the Aid flow from UN agencies (US$) in Syrian Arab Republic in 2008?
Make the answer very short. 2.63e+06. What is the difference between the Aid flow from UN agencies (US$) in East Asia (all income levels) in 2006 and the Aid flow from UN agencies (US$) in Bosnia and Herzegovina in 2009?
Your answer should be very brief. -1.02e+06. What is the difference between the Aid flow from UN agencies (US$) in East Asia (all income levels) in 2006 and the Aid flow from UN agencies (US$) in Malawi in 2009?
Ensure brevity in your answer.  3.20e+05. What is the difference between the Aid flow from UN agencies (US$) in Bosnia and Herzegovina in 2006 and the Aid flow from UN agencies (US$) in Malawi in 2009?
Offer a very short reply. 2.00e+06. What is the difference between the Aid flow from UN agencies (US$) of Bosnia and Herzegovina in 2006 and the Aid flow from UN agencies (US$) of Syrian Arab Republic in 2009?
Your answer should be very brief. 2.17e+06. What is the difference between the Aid flow from UN agencies (US$) of Malawi in 2006 and the Aid flow from UN agencies (US$) of Syrian Arab Republic in 2009?
Your answer should be compact. -5.30e+05. What is the difference between the Aid flow from UN agencies (US$) of East Asia (all income levels) in 2006 and the Aid flow from UN agencies (US$) of Bosnia and Herzegovina in 2010?
Offer a very short reply. 1.08e+06. What is the difference between the Aid flow from UN agencies (US$) in East Asia (all income levels) in 2006 and the Aid flow from UN agencies (US$) in Malawi in 2010?
Provide a succinct answer. 7.20e+05. What is the difference between the Aid flow from UN agencies (US$) in East Asia (all income levels) in 2006 and the Aid flow from UN agencies (US$) in Syrian Arab Republic in 2010?
Make the answer very short. -4.55e+07. What is the difference between the Aid flow from UN agencies (US$) in Bosnia and Herzegovina in 2006 and the Aid flow from UN agencies (US$) in Malawi in 2010?
Provide a succinct answer. 2.40e+06. What is the difference between the Aid flow from UN agencies (US$) in Bosnia and Herzegovina in 2006 and the Aid flow from UN agencies (US$) in Syrian Arab Republic in 2010?
Your response must be concise. -4.39e+07. What is the difference between the Aid flow from UN agencies (US$) in Malawi in 2006 and the Aid flow from UN agencies (US$) in Syrian Arab Republic in 2010?
Give a very brief answer. -4.66e+07. What is the difference between the Aid flow from UN agencies (US$) in East Asia (all income levels) in 2006 and the Aid flow from UN agencies (US$) in Bosnia and Herzegovina in 2012?
Keep it short and to the point. 1.44e+06. What is the difference between the Aid flow from UN agencies (US$) in East Asia (all income levels) in 2006 and the Aid flow from UN agencies (US$) in Malawi in 2012?
Provide a short and direct response. -7.10e+05. What is the difference between the Aid flow from UN agencies (US$) of Bosnia and Herzegovina in 2006 and the Aid flow from UN agencies (US$) of Malawi in 2012?
Offer a terse response. 9.70e+05. What is the difference between the Aid flow from UN agencies (US$) in Bosnia and Herzegovina in 2006 and the Aid flow from UN agencies (US$) in Syrian Arab Republic in 2012?
Your answer should be very brief. 2.23e+06. What is the difference between the Aid flow from UN agencies (US$) in Malawi in 2006 and the Aid flow from UN agencies (US$) in Syrian Arab Republic in 2012?
Your response must be concise. -4.70e+05. What is the difference between the Aid flow from UN agencies (US$) in East Asia (all income levels) in 2007 and the Aid flow from UN agencies (US$) in Bosnia and Herzegovina in 2008?
Ensure brevity in your answer.  8.88e+06. What is the difference between the Aid flow from UN agencies (US$) in East Asia (all income levels) in 2007 and the Aid flow from UN agencies (US$) in Malawi in 2008?
Offer a very short reply. 1.15e+07. What is the difference between the Aid flow from UN agencies (US$) in East Asia (all income levels) in 2007 and the Aid flow from UN agencies (US$) in Syrian Arab Republic in 2008?
Your answer should be very brief. 1.19e+07. What is the difference between the Aid flow from UN agencies (US$) of Bosnia and Herzegovina in 2007 and the Aid flow from UN agencies (US$) of Malawi in 2008?
Keep it short and to the point. 3.55e+06. What is the difference between the Aid flow from UN agencies (US$) of Bosnia and Herzegovina in 2007 and the Aid flow from UN agencies (US$) of Syrian Arab Republic in 2008?
Your answer should be very brief. 3.92e+06. What is the difference between the Aid flow from UN agencies (US$) of Malawi in 2007 and the Aid flow from UN agencies (US$) of Syrian Arab Republic in 2008?
Offer a terse response. 6.30e+05. What is the difference between the Aid flow from UN agencies (US$) of East Asia (all income levels) in 2007 and the Aid flow from UN agencies (US$) of Bosnia and Herzegovina in 2009?
Offer a terse response. 9.92e+06. What is the difference between the Aid flow from UN agencies (US$) in East Asia (all income levels) in 2007 and the Aid flow from UN agencies (US$) in Malawi in 2009?
Provide a succinct answer. 1.13e+07. What is the difference between the Aid flow from UN agencies (US$) of East Asia (all income levels) in 2007 and the Aid flow from UN agencies (US$) of Syrian Arab Republic in 2009?
Offer a terse response. 1.14e+07. What is the difference between the Aid flow from UN agencies (US$) of Bosnia and Herzegovina in 2007 and the Aid flow from UN agencies (US$) of Malawi in 2009?
Your answer should be compact. 3.29e+06. What is the difference between the Aid flow from UN agencies (US$) in Bosnia and Herzegovina in 2007 and the Aid flow from UN agencies (US$) in Syrian Arab Republic in 2009?
Provide a short and direct response. 3.46e+06. What is the difference between the Aid flow from UN agencies (US$) in Malawi in 2007 and the Aid flow from UN agencies (US$) in Syrian Arab Republic in 2009?
Your answer should be very brief. 1.70e+05. What is the difference between the Aid flow from UN agencies (US$) of East Asia (all income levels) in 2007 and the Aid flow from UN agencies (US$) of Bosnia and Herzegovina in 2010?
Provide a short and direct response. 1.20e+07. What is the difference between the Aid flow from UN agencies (US$) in East Asia (all income levels) in 2007 and the Aid flow from UN agencies (US$) in Malawi in 2010?
Make the answer very short. 1.17e+07. What is the difference between the Aid flow from UN agencies (US$) of East Asia (all income levels) in 2007 and the Aid flow from UN agencies (US$) of Syrian Arab Republic in 2010?
Your answer should be compact. -3.46e+07. What is the difference between the Aid flow from UN agencies (US$) of Bosnia and Herzegovina in 2007 and the Aid flow from UN agencies (US$) of Malawi in 2010?
Ensure brevity in your answer.  3.69e+06. What is the difference between the Aid flow from UN agencies (US$) in Bosnia and Herzegovina in 2007 and the Aid flow from UN agencies (US$) in Syrian Arab Republic in 2010?
Your response must be concise. -4.26e+07. What is the difference between the Aid flow from UN agencies (US$) in Malawi in 2007 and the Aid flow from UN agencies (US$) in Syrian Arab Republic in 2010?
Provide a short and direct response. -4.59e+07. What is the difference between the Aid flow from UN agencies (US$) of East Asia (all income levels) in 2007 and the Aid flow from UN agencies (US$) of Bosnia and Herzegovina in 2012?
Your answer should be very brief. 1.24e+07. What is the difference between the Aid flow from UN agencies (US$) of East Asia (all income levels) in 2007 and the Aid flow from UN agencies (US$) of Malawi in 2012?
Keep it short and to the point. 1.02e+07. What is the difference between the Aid flow from UN agencies (US$) in East Asia (all income levels) in 2007 and the Aid flow from UN agencies (US$) in Syrian Arab Republic in 2012?
Keep it short and to the point. 1.15e+07. What is the difference between the Aid flow from UN agencies (US$) of Bosnia and Herzegovina in 2007 and the Aid flow from UN agencies (US$) of Malawi in 2012?
Offer a terse response. 2.26e+06. What is the difference between the Aid flow from UN agencies (US$) of Bosnia and Herzegovina in 2007 and the Aid flow from UN agencies (US$) of Syrian Arab Republic in 2012?
Your response must be concise. 3.52e+06. What is the difference between the Aid flow from UN agencies (US$) in Malawi in 2007 and the Aid flow from UN agencies (US$) in Syrian Arab Republic in 2012?
Make the answer very short. 2.30e+05. What is the difference between the Aid flow from UN agencies (US$) in East Asia (all income levels) in 2008 and the Aid flow from UN agencies (US$) in Bosnia and Herzegovina in 2009?
Ensure brevity in your answer.  1.02e+07. What is the difference between the Aid flow from UN agencies (US$) of East Asia (all income levels) in 2008 and the Aid flow from UN agencies (US$) of Malawi in 2009?
Give a very brief answer. 1.16e+07. What is the difference between the Aid flow from UN agencies (US$) of East Asia (all income levels) in 2008 and the Aid flow from UN agencies (US$) of Syrian Arab Republic in 2009?
Keep it short and to the point. 1.17e+07. What is the difference between the Aid flow from UN agencies (US$) in Bosnia and Herzegovina in 2008 and the Aid flow from UN agencies (US$) in Malawi in 2009?
Provide a succinct answer. 2.38e+06. What is the difference between the Aid flow from UN agencies (US$) in Bosnia and Herzegovina in 2008 and the Aid flow from UN agencies (US$) in Syrian Arab Republic in 2009?
Offer a terse response. 2.55e+06. What is the difference between the Aid flow from UN agencies (US$) in Malawi in 2008 and the Aid flow from UN agencies (US$) in Syrian Arab Republic in 2009?
Your response must be concise. -9.00e+04. What is the difference between the Aid flow from UN agencies (US$) in East Asia (all income levels) in 2008 and the Aid flow from UN agencies (US$) in Bosnia and Herzegovina in 2010?
Keep it short and to the point. 1.23e+07. What is the difference between the Aid flow from UN agencies (US$) of East Asia (all income levels) in 2008 and the Aid flow from UN agencies (US$) of Malawi in 2010?
Make the answer very short. 1.20e+07. What is the difference between the Aid flow from UN agencies (US$) of East Asia (all income levels) in 2008 and the Aid flow from UN agencies (US$) of Syrian Arab Republic in 2010?
Provide a short and direct response. -3.43e+07. What is the difference between the Aid flow from UN agencies (US$) of Bosnia and Herzegovina in 2008 and the Aid flow from UN agencies (US$) of Malawi in 2010?
Your response must be concise. 2.78e+06. What is the difference between the Aid flow from UN agencies (US$) of Bosnia and Herzegovina in 2008 and the Aid flow from UN agencies (US$) of Syrian Arab Republic in 2010?
Make the answer very short. -4.35e+07. What is the difference between the Aid flow from UN agencies (US$) in Malawi in 2008 and the Aid flow from UN agencies (US$) in Syrian Arab Republic in 2010?
Offer a very short reply. -4.61e+07. What is the difference between the Aid flow from UN agencies (US$) in East Asia (all income levels) in 2008 and the Aid flow from UN agencies (US$) in Bosnia and Herzegovina in 2012?
Give a very brief answer. 1.27e+07. What is the difference between the Aid flow from UN agencies (US$) of East Asia (all income levels) in 2008 and the Aid flow from UN agencies (US$) of Malawi in 2012?
Your answer should be compact. 1.05e+07. What is the difference between the Aid flow from UN agencies (US$) in East Asia (all income levels) in 2008 and the Aid flow from UN agencies (US$) in Syrian Arab Republic in 2012?
Your response must be concise. 1.18e+07. What is the difference between the Aid flow from UN agencies (US$) in Bosnia and Herzegovina in 2008 and the Aid flow from UN agencies (US$) in Malawi in 2012?
Give a very brief answer. 1.35e+06. What is the difference between the Aid flow from UN agencies (US$) of Bosnia and Herzegovina in 2008 and the Aid flow from UN agencies (US$) of Syrian Arab Republic in 2012?
Make the answer very short. 2.61e+06. What is the difference between the Aid flow from UN agencies (US$) in Malawi in 2008 and the Aid flow from UN agencies (US$) in Syrian Arab Republic in 2012?
Give a very brief answer. -3.00e+04. What is the difference between the Aid flow from UN agencies (US$) of East Asia (all income levels) in 2009 and the Aid flow from UN agencies (US$) of Bosnia and Herzegovina in 2010?
Provide a short and direct response. 9.26e+06. What is the difference between the Aid flow from UN agencies (US$) of East Asia (all income levels) in 2009 and the Aid flow from UN agencies (US$) of Malawi in 2010?
Keep it short and to the point. 8.90e+06. What is the difference between the Aid flow from UN agencies (US$) of East Asia (all income levels) in 2009 and the Aid flow from UN agencies (US$) of Syrian Arab Republic in 2010?
Keep it short and to the point. -3.74e+07. What is the difference between the Aid flow from UN agencies (US$) in Bosnia and Herzegovina in 2009 and the Aid flow from UN agencies (US$) in Malawi in 2010?
Make the answer very short. 1.74e+06. What is the difference between the Aid flow from UN agencies (US$) in Bosnia and Herzegovina in 2009 and the Aid flow from UN agencies (US$) in Syrian Arab Republic in 2010?
Provide a short and direct response. -4.45e+07. What is the difference between the Aid flow from UN agencies (US$) in Malawi in 2009 and the Aid flow from UN agencies (US$) in Syrian Arab Republic in 2010?
Your answer should be very brief. -4.59e+07. What is the difference between the Aid flow from UN agencies (US$) in East Asia (all income levels) in 2009 and the Aid flow from UN agencies (US$) in Bosnia and Herzegovina in 2012?
Keep it short and to the point. 9.62e+06. What is the difference between the Aid flow from UN agencies (US$) in East Asia (all income levels) in 2009 and the Aid flow from UN agencies (US$) in Malawi in 2012?
Offer a terse response. 7.47e+06. What is the difference between the Aid flow from UN agencies (US$) in East Asia (all income levels) in 2009 and the Aid flow from UN agencies (US$) in Syrian Arab Republic in 2012?
Keep it short and to the point. 8.73e+06. What is the difference between the Aid flow from UN agencies (US$) of Bosnia and Herzegovina in 2009 and the Aid flow from UN agencies (US$) of Syrian Arab Republic in 2012?
Give a very brief answer. 1.57e+06. What is the difference between the Aid flow from UN agencies (US$) in East Asia (all income levels) in 2010 and the Aid flow from UN agencies (US$) in Bosnia and Herzegovina in 2012?
Your response must be concise. 1.06e+07. What is the difference between the Aid flow from UN agencies (US$) of East Asia (all income levels) in 2010 and the Aid flow from UN agencies (US$) of Malawi in 2012?
Ensure brevity in your answer.  8.43e+06. What is the difference between the Aid flow from UN agencies (US$) in East Asia (all income levels) in 2010 and the Aid flow from UN agencies (US$) in Syrian Arab Republic in 2012?
Offer a terse response. 9.69e+06. What is the difference between the Aid flow from UN agencies (US$) of Bosnia and Herzegovina in 2010 and the Aid flow from UN agencies (US$) of Malawi in 2012?
Provide a succinct answer. -1.79e+06. What is the difference between the Aid flow from UN agencies (US$) in Bosnia and Herzegovina in 2010 and the Aid flow from UN agencies (US$) in Syrian Arab Republic in 2012?
Provide a short and direct response. -5.30e+05. What is the difference between the Aid flow from UN agencies (US$) in Malawi in 2010 and the Aid flow from UN agencies (US$) in Syrian Arab Republic in 2012?
Give a very brief answer. -1.70e+05. What is the average Aid flow from UN agencies (US$) in East Asia (all income levels) per year?
Keep it short and to the point. 1.09e+07. What is the average Aid flow from UN agencies (US$) of Bosnia and Herzegovina per year?
Your answer should be compact. 3.88e+06. What is the average Aid flow from UN agencies (US$) of Malawi per year?
Your response must be concise. 1.08e+06. What is the average Aid flow from UN agencies (US$) in Syrian Arab Republic per year?
Make the answer very short. 6.47e+06. In the year 2003, what is the difference between the Aid flow from UN agencies (US$) in East Asia (all income levels) and Aid flow from UN agencies (US$) in Bosnia and Herzegovina?
Provide a succinct answer. 6.97e+06. In the year 2003, what is the difference between the Aid flow from UN agencies (US$) of East Asia (all income levels) and Aid flow from UN agencies (US$) of Malawi?
Keep it short and to the point. 1.86e+07. In the year 2003, what is the difference between the Aid flow from UN agencies (US$) in East Asia (all income levels) and Aid flow from UN agencies (US$) in Syrian Arab Republic?
Make the answer very short. 1.89e+07. In the year 2003, what is the difference between the Aid flow from UN agencies (US$) of Bosnia and Herzegovina and Aid flow from UN agencies (US$) of Malawi?
Offer a very short reply. 1.16e+07. In the year 2003, what is the difference between the Aid flow from UN agencies (US$) of Bosnia and Herzegovina and Aid flow from UN agencies (US$) of Syrian Arab Republic?
Give a very brief answer. 1.19e+07. In the year 2003, what is the difference between the Aid flow from UN agencies (US$) of Malawi and Aid flow from UN agencies (US$) of Syrian Arab Republic?
Offer a terse response. 3.20e+05. In the year 2005, what is the difference between the Aid flow from UN agencies (US$) of East Asia (all income levels) and Aid flow from UN agencies (US$) of Bosnia and Herzegovina?
Ensure brevity in your answer.  3.15e+06. In the year 2005, what is the difference between the Aid flow from UN agencies (US$) in East Asia (all income levels) and Aid flow from UN agencies (US$) in Malawi?
Provide a short and direct response. 6.40e+06. In the year 2005, what is the difference between the Aid flow from UN agencies (US$) in East Asia (all income levels) and Aid flow from UN agencies (US$) in Syrian Arab Republic?
Keep it short and to the point. 6.42e+06. In the year 2005, what is the difference between the Aid flow from UN agencies (US$) in Bosnia and Herzegovina and Aid flow from UN agencies (US$) in Malawi?
Offer a very short reply. 3.25e+06. In the year 2005, what is the difference between the Aid flow from UN agencies (US$) of Bosnia and Herzegovina and Aid flow from UN agencies (US$) of Syrian Arab Republic?
Give a very brief answer. 3.27e+06. In the year 2005, what is the difference between the Aid flow from UN agencies (US$) of Malawi and Aid flow from UN agencies (US$) of Syrian Arab Republic?
Provide a short and direct response. 2.00e+04. In the year 2006, what is the difference between the Aid flow from UN agencies (US$) of East Asia (all income levels) and Aid flow from UN agencies (US$) of Bosnia and Herzegovina?
Your answer should be compact. -1.68e+06. In the year 2006, what is the difference between the Aid flow from UN agencies (US$) in East Asia (all income levels) and Aid flow from UN agencies (US$) in Malawi?
Make the answer very short. 1.02e+06. In the year 2006, what is the difference between the Aid flow from UN agencies (US$) in East Asia (all income levels) and Aid flow from UN agencies (US$) in Syrian Arab Republic?
Offer a terse response. 1.11e+06. In the year 2006, what is the difference between the Aid flow from UN agencies (US$) of Bosnia and Herzegovina and Aid flow from UN agencies (US$) of Malawi?
Your answer should be very brief. 2.70e+06. In the year 2006, what is the difference between the Aid flow from UN agencies (US$) in Bosnia and Herzegovina and Aid flow from UN agencies (US$) in Syrian Arab Republic?
Provide a succinct answer. 2.79e+06. In the year 2006, what is the difference between the Aid flow from UN agencies (US$) of Malawi and Aid flow from UN agencies (US$) of Syrian Arab Republic?
Your response must be concise. 9.00e+04. In the year 2007, what is the difference between the Aid flow from UN agencies (US$) in East Asia (all income levels) and Aid flow from UN agencies (US$) in Bosnia and Herzegovina?
Provide a succinct answer. 7.97e+06. In the year 2007, what is the difference between the Aid flow from UN agencies (US$) of East Asia (all income levels) and Aid flow from UN agencies (US$) of Malawi?
Your response must be concise. 1.13e+07. In the year 2007, what is the difference between the Aid flow from UN agencies (US$) in East Asia (all income levels) and Aid flow from UN agencies (US$) in Syrian Arab Republic?
Your answer should be compact. 1.22e+07. In the year 2007, what is the difference between the Aid flow from UN agencies (US$) in Bosnia and Herzegovina and Aid flow from UN agencies (US$) in Malawi?
Give a very brief answer. 3.29e+06. In the year 2007, what is the difference between the Aid flow from UN agencies (US$) of Bosnia and Herzegovina and Aid flow from UN agencies (US$) of Syrian Arab Republic?
Ensure brevity in your answer.  4.23e+06. In the year 2007, what is the difference between the Aid flow from UN agencies (US$) in Malawi and Aid flow from UN agencies (US$) in Syrian Arab Republic?
Your answer should be very brief. 9.40e+05. In the year 2008, what is the difference between the Aid flow from UN agencies (US$) in East Asia (all income levels) and Aid flow from UN agencies (US$) in Bosnia and Herzegovina?
Your response must be concise. 9.18e+06. In the year 2008, what is the difference between the Aid flow from UN agencies (US$) in East Asia (all income levels) and Aid flow from UN agencies (US$) in Malawi?
Ensure brevity in your answer.  1.18e+07. In the year 2008, what is the difference between the Aid flow from UN agencies (US$) in East Asia (all income levels) and Aid flow from UN agencies (US$) in Syrian Arab Republic?
Provide a succinct answer. 1.22e+07. In the year 2008, what is the difference between the Aid flow from UN agencies (US$) of Bosnia and Herzegovina and Aid flow from UN agencies (US$) of Malawi?
Give a very brief answer. 2.64e+06. In the year 2008, what is the difference between the Aid flow from UN agencies (US$) of Bosnia and Herzegovina and Aid flow from UN agencies (US$) of Syrian Arab Republic?
Your response must be concise. 3.01e+06. In the year 2009, what is the difference between the Aid flow from UN agencies (US$) in East Asia (all income levels) and Aid flow from UN agencies (US$) in Bosnia and Herzegovina?
Give a very brief answer. 7.16e+06. In the year 2009, what is the difference between the Aid flow from UN agencies (US$) of East Asia (all income levels) and Aid flow from UN agencies (US$) of Malawi?
Ensure brevity in your answer.  8.50e+06. In the year 2009, what is the difference between the Aid flow from UN agencies (US$) of East Asia (all income levels) and Aid flow from UN agencies (US$) of Syrian Arab Republic?
Keep it short and to the point. 8.67e+06. In the year 2009, what is the difference between the Aid flow from UN agencies (US$) in Bosnia and Herzegovina and Aid flow from UN agencies (US$) in Malawi?
Keep it short and to the point. 1.34e+06. In the year 2009, what is the difference between the Aid flow from UN agencies (US$) of Bosnia and Herzegovina and Aid flow from UN agencies (US$) of Syrian Arab Republic?
Offer a terse response. 1.51e+06. In the year 2010, what is the difference between the Aid flow from UN agencies (US$) of East Asia (all income levels) and Aid flow from UN agencies (US$) of Bosnia and Herzegovina?
Offer a very short reply. 1.02e+07. In the year 2010, what is the difference between the Aid flow from UN agencies (US$) of East Asia (all income levels) and Aid flow from UN agencies (US$) of Malawi?
Your answer should be very brief. 9.86e+06. In the year 2010, what is the difference between the Aid flow from UN agencies (US$) of East Asia (all income levels) and Aid flow from UN agencies (US$) of Syrian Arab Republic?
Offer a very short reply. -3.64e+07. In the year 2010, what is the difference between the Aid flow from UN agencies (US$) in Bosnia and Herzegovina and Aid flow from UN agencies (US$) in Malawi?
Your answer should be compact. -3.60e+05. In the year 2010, what is the difference between the Aid flow from UN agencies (US$) of Bosnia and Herzegovina and Aid flow from UN agencies (US$) of Syrian Arab Republic?
Make the answer very short. -4.66e+07. In the year 2010, what is the difference between the Aid flow from UN agencies (US$) of Malawi and Aid flow from UN agencies (US$) of Syrian Arab Republic?
Offer a very short reply. -4.63e+07. In the year 2012, what is the difference between the Aid flow from UN agencies (US$) of East Asia (all income levels) and Aid flow from UN agencies (US$) of Bosnia and Herzegovina?
Provide a succinct answer. 1.33e+07. In the year 2012, what is the difference between the Aid flow from UN agencies (US$) in East Asia (all income levels) and Aid flow from UN agencies (US$) in Malawi?
Your response must be concise. 1.12e+07. In the year 2012, what is the difference between the Aid flow from UN agencies (US$) of East Asia (all income levels) and Aid flow from UN agencies (US$) of Syrian Arab Republic?
Make the answer very short. 1.24e+07. In the year 2012, what is the difference between the Aid flow from UN agencies (US$) in Bosnia and Herzegovina and Aid flow from UN agencies (US$) in Malawi?
Offer a terse response. -2.15e+06. In the year 2012, what is the difference between the Aid flow from UN agencies (US$) of Bosnia and Herzegovina and Aid flow from UN agencies (US$) of Syrian Arab Republic?
Provide a succinct answer. -8.90e+05. In the year 2012, what is the difference between the Aid flow from UN agencies (US$) of Malawi and Aid flow from UN agencies (US$) of Syrian Arab Republic?
Give a very brief answer. 1.26e+06. What is the ratio of the Aid flow from UN agencies (US$) of East Asia (all income levels) in 2003 to that in 2005?
Provide a short and direct response. 2.81. What is the ratio of the Aid flow from UN agencies (US$) in Bosnia and Herzegovina in 2003 to that in 2005?
Your response must be concise. 3.29. What is the ratio of the Aid flow from UN agencies (US$) in Malawi in 2003 to that in 2005?
Give a very brief answer. 1.97. What is the ratio of the Aid flow from UN agencies (US$) in Syrian Arab Republic in 2003 to that in 2005?
Provide a succinct answer. 1.57. What is the ratio of the Aid flow from UN agencies (US$) of East Asia (all income levels) in 2003 to that in 2006?
Keep it short and to the point. 13.6. What is the ratio of the Aid flow from UN agencies (US$) in Bosnia and Herzegovina in 2003 to that in 2006?
Provide a short and direct response. 4.13. What is the ratio of the Aid flow from UN agencies (US$) in Malawi in 2003 to that in 2006?
Offer a very short reply. 3.11. What is the ratio of the Aid flow from UN agencies (US$) of Syrian Arab Republic in 2003 to that in 2006?
Your answer should be compact. 3. What is the ratio of the Aid flow from UN agencies (US$) of East Asia (all income levels) in 2003 to that in 2007?
Your response must be concise. 1.61. What is the ratio of the Aid flow from UN agencies (US$) of Bosnia and Herzegovina in 2003 to that in 2007?
Offer a terse response. 2.93. What is the ratio of the Aid flow from UN agencies (US$) in Malawi in 2003 to that in 2007?
Keep it short and to the point. 1.22. What is the ratio of the Aid flow from UN agencies (US$) of Syrian Arab Republic in 2003 to that in 2007?
Ensure brevity in your answer.  5.14. What is the ratio of the Aid flow from UN agencies (US$) in East Asia (all income levels) in 2003 to that in 2008?
Your response must be concise. 1.57. What is the ratio of the Aid flow from UN agencies (US$) of Bosnia and Herzegovina in 2003 to that in 2008?
Your response must be concise. 3.69. What is the ratio of the Aid flow from UN agencies (US$) of Malawi in 2003 to that in 2008?
Your response must be concise. 1.57. What is the ratio of the Aid flow from UN agencies (US$) in Syrian Arab Republic in 2003 to that in 2008?
Give a very brief answer. 2.08. What is the ratio of the Aid flow from UN agencies (US$) of East Asia (all income levels) in 2003 to that in 2009?
Make the answer very short. 2.07. What is the ratio of the Aid flow from UN agencies (US$) in Bosnia and Herzegovina in 2003 to that in 2009?
Keep it short and to the point. 5.23. What is the ratio of the Aid flow from UN agencies (US$) of Malawi in 2003 to that in 2009?
Your response must be concise. 1.22. What is the ratio of the Aid flow from UN agencies (US$) of Syrian Arab Republic in 2003 to that in 2009?
Keep it short and to the point. 1.1. What is the ratio of the Aid flow from UN agencies (US$) in East Asia (all income levels) in 2003 to that in 2010?
Your response must be concise. 1.88. What is the ratio of the Aid flow from UN agencies (US$) of Bosnia and Herzegovina in 2003 to that in 2010?
Keep it short and to the point. 33.38. What is the ratio of the Aid flow from UN agencies (US$) in Malawi in 2003 to that in 2010?
Make the answer very short. 1.87. What is the ratio of the Aid flow from UN agencies (US$) in Syrian Arab Republic in 2003 to that in 2010?
Your answer should be compact. 0.02. What is the ratio of the Aid flow from UN agencies (US$) of East Asia (all income levels) in 2003 to that in 2012?
Give a very brief answer. 1.5. What is the ratio of the Aid flow from UN agencies (US$) of Bosnia and Herzegovina in 2003 to that in 2012?
Offer a terse response. 434. What is the ratio of the Aid flow from UN agencies (US$) in Malawi in 2003 to that in 2012?
Provide a short and direct response. 0.64. What is the ratio of the Aid flow from UN agencies (US$) in Syrian Arab Republic in 2003 to that in 2012?
Provide a short and direct response. 1.17. What is the ratio of the Aid flow from UN agencies (US$) of East Asia (all income levels) in 2005 to that in 2006?
Provide a succinct answer. 4.84. What is the ratio of the Aid flow from UN agencies (US$) of Bosnia and Herzegovina in 2005 to that in 2006?
Make the answer very short. 1.26. What is the ratio of the Aid flow from UN agencies (US$) in Malawi in 2005 to that in 2006?
Provide a short and direct response. 1.58. What is the ratio of the Aid flow from UN agencies (US$) of Syrian Arab Republic in 2005 to that in 2006?
Give a very brief answer. 1.92. What is the ratio of the Aid flow from UN agencies (US$) of East Asia (all income levels) in 2005 to that in 2007?
Offer a very short reply. 0.57. What is the ratio of the Aid flow from UN agencies (US$) in Bosnia and Herzegovina in 2005 to that in 2007?
Your answer should be very brief. 0.89. What is the ratio of the Aid flow from UN agencies (US$) of Malawi in 2005 to that in 2007?
Your answer should be very brief. 0.62. What is the ratio of the Aid flow from UN agencies (US$) of Syrian Arab Republic in 2005 to that in 2007?
Offer a very short reply. 3.29. What is the ratio of the Aid flow from UN agencies (US$) in East Asia (all income levels) in 2005 to that in 2008?
Offer a very short reply. 0.56. What is the ratio of the Aid flow from UN agencies (US$) of Bosnia and Herzegovina in 2005 to that in 2008?
Your answer should be very brief. 1.12. What is the ratio of the Aid flow from UN agencies (US$) of Malawi in 2005 to that in 2008?
Ensure brevity in your answer.  0.8. What is the ratio of the Aid flow from UN agencies (US$) in Syrian Arab Republic in 2005 to that in 2008?
Keep it short and to the point. 1.33. What is the ratio of the Aid flow from UN agencies (US$) of East Asia (all income levels) in 2005 to that in 2009?
Offer a terse response. 0.74. What is the ratio of the Aid flow from UN agencies (US$) of Bosnia and Herzegovina in 2005 to that in 2009?
Provide a succinct answer. 1.59. What is the ratio of the Aid flow from UN agencies (US$) in Malawi in 2005 to that in 2009?
Your response must be concise. 0.62. What is the ratio of the Aid flow from UN agencies (US$) in Syrian Arab Republic in 2005 to that in 2009?
Offer a very short reply. 0.7. What is the ratio of the Aid flow from UN agencies (US$) of East Asia (all income levels) in 2005 to that in 2010?
Provide a short and direct response. 0.67. What is the ratio of the Aid flow from UN agencies (US$) of Bosnia and Herzegovina in 2005 to that in 2010?
Keep it short and to the point. 10.15. What is the ratio of the Aid flow from UN agencies (US$) of Malawi in 2005 to that in 2010?
Your answer should be compact. 0.95. What is the ratio of the Aid flow from UN agencies (US$) of Syrian Arab Republic in 2005 to that in 2010?
Ensure brevity in your answer.  0.01. What is the ratio of the Aid flow from UN agencies (US$) in East Asia (all income levels) in 2005 to that in 2012?
Offer a very short reply. 0.53. What is the ratio of the Aid flow from UN agencies (US$) of Bosnia and Herzegovina in 2005 to that in 2012?
Offer a very short reply. 132. What is the ratio of the Aid flow from UN agencies (US$) of Malawi in 2005 to that in 2012?
Ensure brevity in your answer.  0.33. What is the ratio of the Aid flow from UN agencies (US$) in East Asia (all income levels) in 2006 to that in 2007?
Provide a short and direct response. 0.12. What is the ratio of the Aid flow from UN agencies (US$) of Bosnia and Herzegovina in 2006 to that in 2007?
Your answer should be very brief. 0.71. What is the ratio of the Aid flow from UN agencies (US$) in Malawi in 2006 to that in 2007?
Make the answer very short. 0.39. What is the ratio of the Aid flow from UN agencies (US$) in Syrian Arab Republic in 2006 to that in 2007?
Provide a succinct answer. 1.71. What is the ratio of the Aid flow from UN agencies (US$) of East Asia (all income levels) in 2006 to that in 2008?
Offer a terse response. 0.12. What is the ratio of the Aid flow from UN agencies (US$) of Bosnia and Herzegovina in 2006 to that in 2008?
Ensure brevity in your answer.  0.89. What is the ratio of the Aid flow from UN agencies (US$) of Malawi in 2006 to that in 2008?
Make the answer very short. 0.51. What is the ratio of the Aid flow from UN agencies (US$) of Syrian Arab Republic in 2006 to that in 2008?
Give a very brief answer. 0.69. What is the ratio of the Aid flow from UN agencies (US$) of East Asia (all income levels) in 2006 to that in 2009?
Your answer should be very brief. 0.15. What is the ratio of the Aid flow from UN agencies (US$) of Bosnia and Herzegovina in 2006 to that in 2009?
Offer a very short reply. 1.27. What is the ratio of the Aid flow from UN agencies (US$) in Malawi in 2006 to that in 2009?
Ensure brevity in your answer.  0.39. What is the ratio of the Aid flow from UN agencies (US$) in Syrian Arab Republic in 2006 to that in 2009?
Your answer should be very brief. 0.37. What is the ratio of the Aid flow from UN agencies (US$) of East Asia (all income levels) in 2006 to that in 2010?
Offer a very short reply. 0.14. What is the ratio of the Aid flow from UN agencies (US$) of Bosnia and Herzegovina in 2006 to that in 2010?
Make the answer very short. 8.08. What is the ratio of the Aid flow from UN agencies (US$) of Malawi in 2006 to that in 2010?
Provide a succinct answer. 0.6. What is the ratio of the Aid flow from UN agencies (US$) of Syrian Arab Republic in 2006 to that in 2010?
Your response must be concise. 0.01. What is the ratio of the Aid flow from UN agencies (US$) of East Asia (all income levels) in 2006 to that in 2012?
Make the answer very short. 0.11. What is the ratio of the Aid flow from UN agencies (US$) of Bosnia and Herzegovina in 2006 to that in 2012?
Offer a terse response. 105. What is the ratio of the Aid flow from UN agencies (US$) in Malawi in 2006 to that in 2012?
Your answer should be compact. 0.21. What is the ratio of the Aid flow from UN agencies (US$) in Syrian Arab Republic in 2006 to that in 2012?
Offer a very short reply. 0.39. What is the ratio of the Aid flow from UN agencies (US$) in East Asia (all income levels) in 2007 to that in 2008?
Provide a short and direct response. 0.98. What is the ratio of the Aid flow from UN agencies (US$) in Bosnia and Herzegovina in 2007 to that in 2008?
Keep it short and to the point. 1.26. What is the ratio of the Aid flow from UN agencies (US$) of Malawi in 2007 to that in 2008?
Offer a very short reply. 1.29. What is the ratio of the Aid flow from UN agencies (US$) of Syrian Arab Republic in 2007 to that in 2008?
Provide a succinct answer. 0.4. What is the ratio of the Aid flow from UN agencies (US$) of East Asia (all income levels) in 2007 to that in 2009?
Your answer should be very brief. 1.29. What is the ratio of the Aid flow from UN agencies (US$) of Bosnia and Herzegovina in 2007 to that in 2009?
Your answer should be compact. 1.78. What is the ratio of the Aid flow from UN agencies (US$) of Syrian Arab Republic in 2007 to that in 2009?
Make the answer very short. 0.21. What is the ratio of the Aid flow from UN agencies (US$) of East Asia (all income levels) in 2007 to that in 2010?
Keep it short and to the point. 1.17. What is the ratio of the Aid flow from UN agencies (US$) of Bosnia and Herzegovina in 2007 to that in 2010?
Your answer should be compact. 11.38. What is the ratio of the Aid flow from UN agencies (US$) of Malawi in 2007 to that in 2010?
Give a very brief answer. 1.53. What is the ratio of the Aid flow from UN agencies (US$) of Syrian Arab Republic in 2007 to that in 2010?
Offer a terse response. 0. What is the ratio of the Aid flow from UN agencies (US$) in East Asia (all income levels) in 2007 to that in 2012?
Provide a succinct answer. 0.93. What is the ratio of the Aid flow from UN agencies (US$) of Bosnia and Herzegovina in 2007 to that in 2012?
Your response must be concise. 148. What is the ratio of the Aid flow from UN agencies (US$) in Malawi in 2007 to that in 2012?
Your answer should be very brief. 0.53. What is the ratio of the Aid flow from UN agencies (US$) in Syrian Arab Republic in 2007 to that in 2012?
Your answer should be compact. 0.23. What is the ratio of the Aid flow from UN agencies (US$) in East Asia (all income levels) in 2008 to that in 2009?
Your answer should be compact. 1.32. What is the ratio of the Aid flow from UN agencies (US$) in Bosnia and Herzegovina in 2008 to that in 2009?
Offer a terse response. 1.42. What is the ratio of the Aid flow from UN agencies (US$) of Malawi in 2008 to that in 2009?
Your answer should be very brief. 0.77. What is the ratio of the Aid flow from UN agencies (US$) in Syrian Arab Republic in 2008 to that in 2009?
Ensure brevity in your answer.  0.53. What is the ratio of the Aid flow from UN agencies (US$) in East Asia (all income levels) in 2008 to that in 2010?
Your answer should be compact. 1.2. What is the ratio of the Aid flow from UN agencies (US$) of Bosnia and Herzegovina in 2008 to that in 2010?
Your response must be concise. 9.05. What is the ratio of the Aid flow from UN agencies (US$) of Malawi in 2008 to that in 2010?
Your response must be concise. 1.19. What is the ratio of the Aid flow from UN agencies (US$) of Syrian Arab Republic in 2008 to that in 2010?
Ensure brevity in your answer.  0.01. What is the ratio of the Aid flow from UN agencies (US$) in East Asia (all income levels) in 2008 to that in 2012?
Make the answer very short. 0.95. What is the ratio of the Aid flow from UN agencies (US$) in Bosnia and Herzegovina in 2008 to that in 2012?
Make the answer very short. 117.67. What is the ratio of the Aid flow from UN agencies (US$) in Malawi in 2008 to that in 2012?
Offer a very short reply. 0.41. What is the ratio of the Aid flow from UN agencies (US$) in Syrian Arab Republic in 2008 to that in 2012?
Ensure brevity in your answer.  0.57. What is the ratio of the Aid flow from UN agencies (US$) in East Asia (all income levels) in 2009 to that in 2010?
Ensure brevity in your answer.  0.91. What is the ratio of the Aid flow from UN agencies (US$) in Bosnia and Herzegovina in 2009 to that in 2010?
Offer a very short reply. 6.38. What is the ratio of the Aid flow from UN agencies (US$) of Malawi in 2009 to that in 2010?
Your answer should be very brief. 1.53. What is the ratio of the Aid flow from UN agencies (US$) of Syrian Arab Republic in 2009 to that in 2010?
Your response must be concise. 0.02. What is the ratio of the Aid flow from UN agencies (US$) in East Asia (all income levels) in 2009 to that in 2012?
Make the answer very short. 0.72. What is the ratio of the Aid flow from UN agencies (US$) of Malawi in 2009 to that in 2012?
Provide a short and direct response. 0.53. What is the ratio of the Aid flow from UN agencies (US$) in Syrian Arab Republic in 2009 to that in 2012?
Your response must be concise. 1.07. What is the ratio of the Aid flow from UN agencies (US$) of East Asia (all income levels) in 2010 to that in 2012?
Provide a short and direct response. 0.8. What is the ratio of the Aid flow from UN agencies (US$) of Malawi in 2010 to that in 2012?
Your response must be concise. 0.34. What is the ratio of the Aid flow from UN agencies (US$) of Syrian Arab Republic in 2010 to that in 2012?
Your answer should be very brief. 51.1. What is the difference between the highest and the second highest Aid flow from UN agencies (US$) in East Asia (all income levels)?
Keep it short and to the point. 6.65e+06. What is the difference between the highest and the second highest Aid flow from UN agencies (US$) in Bosnia and Herzegovina?
Give a very brief answer. 8.58e+06. What is the difference between the highest and the second highest Aid flow from UN agencies (US$) in Malawi?
Your answer should be very brief. 7.80e+05. What is the difference between the highest and the second highest Aid flow from UN agencies (US$) in Syrian Arab Republic?
Provide a succinct answer. 4.59e+07. What is the difference between the highest and the lowest Aid flow from UN agencies (US$) of East Asia (all income levels)?
Provide a short and direct response. 1.85e+07. What is the difference between the highest and the lowest Aid flow from UN agencies (US$) in Bosnia and Herzegovina?
Provide a short and direct response. 1.30e+07. What is the difference between the highest and the lowest Aid flow from UN agencies (US$) in Malawi?
Offer a very short reply. 1.73e+06. What is the difference between the highest and the lowest Aid flow from UN agencies (US$) of Syrian Arab Republic?
Keep it short and to the point. 4.68e+07. 